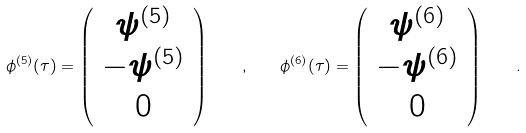Convert formula to latex. <formula><loc_0><loc_0><loc_500><loc_500>\phi ^ { ( 5 ) } ( \tau ) = \left ( \begin{array} { c } \psi ^ { ( 5 ) } \\ - \psi ^ { ( 5 ) } \\ 0 \end{array} \right ) \quad , \quad \phi ^ { ( 6 ) } ( \tau ) = \left ( \begin{array} { c } \psi ^ { ( 6 ) } \\ - \psi ^ { ( 6 ) } \\ 0 \end{array} \right ) \quad .</formula> 